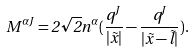<formula> <loc_0><loc_0><loc_500><loc_500>M ^ { \alpha J } = 2 \sqrt { 2 } n ^ { \alpha } ( \frac { q ^ { J } } { | \vec { x } | } - \frac { q ^ { J } } { | \vec { x } - \vec { l } | } ) .</formula> 